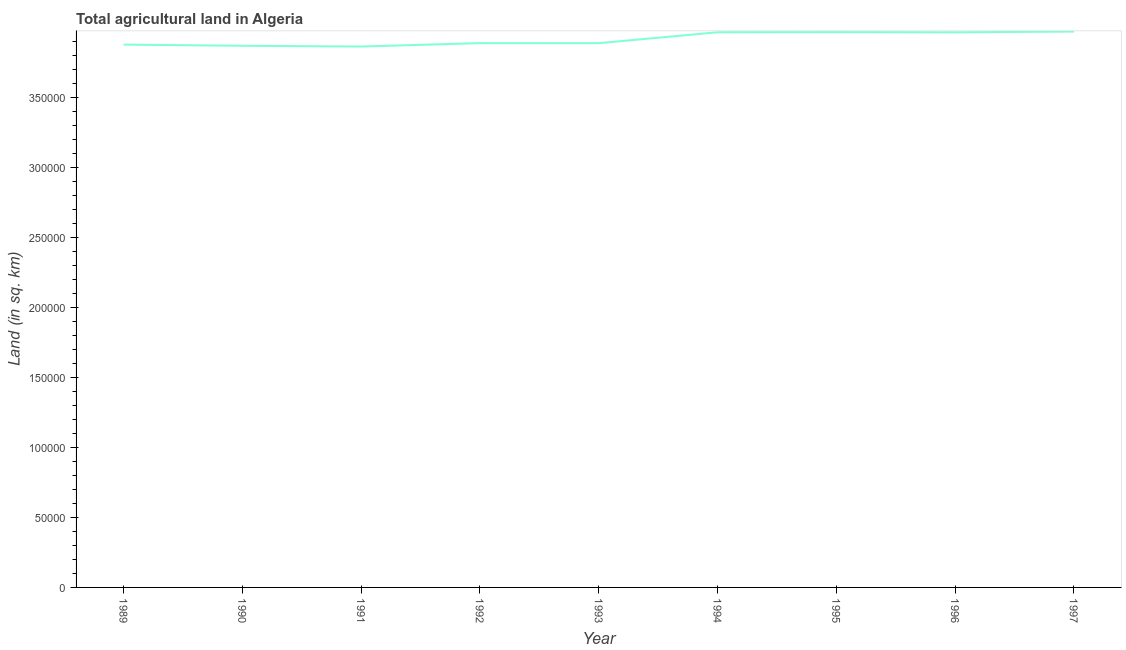What is the agricultural land in 1997?
Offer a terse response. 3.97e+05. Across all years, what is the maximum agricultural land?
Your answer should be compact. 3.97e+05. Across all years, what is the minimum agricultural land?
Make the answer very short. 3.86e+05. In which year was the agricultural land maximum?
Provide a succinct answer. 1997. In which year was the agricultural land minimum?
Provide a short and direct response. 1991. What is the sum of the agricultural land?
Your answer should be very brief. 3.52e+06. What is the difference between the agricultural land in 1991 and 1996?
Make the answer very short. -1.01e+04. What is the average agricultural land per year?
Ensure brevity in your answer.  3.92e+05. What is the median agricultural land?
Ensure brevity in your answer.  3.89e+05. In how many years, is the agricultural land greater than 140000 sq. km?
Provide a succinct answer. 9. What is the ratio of the agricultural land in 1992 to that in 1993?
Make the answer very short. 1. Is the agricultural land in 1991 less than that in 1994?
Your answer should be compact. Yes. Is the difference between the agricultural land in 1989 and 1993 greater than the difference between any two years?
Make the answer very short. No. What is the difference between the highest and the second highest agricultural land?
Offer a very short reply. 410. Is the sum of the agricultural land in 1991 and 1995 greater than the maximum agricultural land across all years?
Provide a short and direct response. Yes. What is the difference between the highest and the lowest agricultural land?
Make the answer very short. 1.07e+04. In how many years, is the agricultural land greater than the average agricultural land taken over all years?
Your response must be concise. 4. How many lines are there?
Offer a terse response. 1. How many years are there in the graph?
Your answer should be compact. 9. Does the graph contain grids?
Your response must be concise. No. What is the title of the graph?
Offer a very short reply. Total agricultural land in Algeria. What is the label or title of the Y-axis?
Ensure brevity in your answer.  Land (in sq. km). What is the Land (in sq. km) of 1989?
Your answer should be compact. 3.88e+05. What is the Land (in sq. km) in 1990?
Give a very brief answer. 3.87e+05. What is the Land (in sq. km) of 1991?
Provide a succinct answer. 3.86e+05. What is the Land (in sq. km) in 1992?
Your answer should be compact. 3.89e+05. What is the Land (in sq. km) of 1993?
Ensure brevity in your answer.  3.89e+05. What is the Land (in sq. km) of 1994?
Keep it short and to the point. 3.96e+05. What is the Land (in sq. km) of 1995?
Give a very brief answer. 3.96e+05. What is the Land (in sq. km) in 1996?
Ensure brevity in your answer.  3.96e+05. What is the Land (in sq. km) of 1997?
Offer a very short reply. 3.97e+05. What is the difference between the Land (in sq. km) in 1989 and 1990?
Your answer should be compact. 840. What is the difference between the Land (in sq. km) in 1989 and 1991?
Offer a very short reply. 1380. What is the difference between the Land (in sq. km) in 1989 and 1992?
Your response must be concise. -1050. What is the difference between the Land (in sq. km) in 1989 and 1993?
Provide a succinct answer. -1020. What is the difference between the Land (in sq. km) in 1989 and 1994?
Keep it short and to the point. -8800. What is the difference between the Land (in sq. km) in 1989 and 1995?
Provide a succinct answer. -8890. What is the difference between the Land (in sq. km) in 1989 and 1996?
Offer a terse response. -8760. What is the difference between the Land (in sq. km) in 1989 and 1997?
Ensure brevity in your answer.  -9300. What is the difference between the Land (in sq. km) in 1990 and 1991?
Provide a short and direct response. 540. What is the difference between the Land (in sq. km) in 1990 and 1992?
Offer a terse response. -1890. What is the difference between the Land (in sq. km) in 1990 and 1993?
Provide a short and direct response. -1860. What is the difference between the Land (in sq. km) in 1990 and 1994?
Give a very brief answer. -9640. What is the difference between the Land (in sq. km) in 1990 and 1995?
Your answer should be very brief. -9730. What is the difference between the Land (in sq. km) in 1990 and 1996?
Provide a short and direct response. -9600. What is the difference between the Land (in sq. km) in 1990 and 1997?
Your response must be concise. -1.01e+04. What is the difference between the Land (in sq. km) in 1991 and 1992?
Make the answer very short. -2430. What is the difference between the Land (in sq. km) in 1991 and 1993?
Offer a very short reply. -2400. What is the difference between the Land (in sq. km) in 1991 and 1994?
Your answer should be compact. -1.02e+04. What is the difference between the Land (in sq. km) in 1991 and 1995?
Give a very brief answer. -1.03e+04. What is the difference between the Land (in sq. km) in 1991 and 1996?
Provide a short and direct response. -1.01e+04. What is the difference between the Land (in sq. km) in 1991 and 1997?
Your response must be concise. -1.07e+04. What is the difference between the Land (in sq. km) in 1992 and 1993?
Give a very brief answer. 30. What is the difference between the Land (in sq. km) in 1992 and 1994?
Your answer should be very brief. -7750. What is the difference between the Land (in sq. km) in 1992 and 1995?
Your answer should be compact. -7840. What is the difference between the Land (in sq. km) in 1992 and 1996?
Keep it short and to the point. -7710. What is the difference between the Land (in sq. km) in 1992 and 1997?
Ensure brevity in your answer.  -8250. What is the difference between the Land (in sq. km) in 1993 and 1994?
Give a very brief answer. -7780. What is the difference between the Land (in sq. km) in 1993 and 1995?
Your answer should be very brief. -7870. What is the difference between the Land (in sq. km) in 1993 and 1996?
Offer a very short reply. -7740. What is the difference between the Land (in sq. km) in 1993 and 1997?
Keep it short and to the point. -8280. What is the difference between the Land (in sq. km) in 1994 and 1995?
Ensure brevity in your answer.  -90. What is the difference between the Land (in sq. km) in 1994 and 1997?
Give a very brief answer. -500. What is the difference between the Land (in sq. km) in 1995 and 1996?
Give a very brief answer. 130. What is the difference between the Land (in sq. km) in 1995 and 1997?
Make the answer very short. -410. What is the difference between the Land (in sq. km) in 1996 and 1997?
Provide a short and direct response. -540. What is the ratio of the Land (in sq. km) in 1989 to that in 1990?
Ensure brevity in your answer.  1. What is the ratio of the Land (in sq. km) in 1990 to that in 1991?
Give a very brief answer. 1. What is the ratio of the Land (in sq. km) in 1990 to that in 1993?
Offer a very short reply. 0.99. What is the ratio of the Land (in sq. km) in 1990 to that in 1994?
Provide a succinct answer. 0.98. What is the ratio of the Land (in sq. km) in 1990 to that in 1995?
Your response must be concise. 0.97. What is the ratio of the Land (in sq. km) in 1991 to that in 1993?
Your answer should be compact. 0.99. What is the ratio of the Land (in sq. km) in 1991 to that in 1994?
Give a very brief answer. 0.97. What is the ratio of the Land (in sq. km) in 1992 to that in 1994?
Offer a terse response. 0.98. What is the ratio of the Land (in sq. km) in 1993 to that in 1995?
Provide a succinct answer. 0.98. What is the ratio of the Land (in sq. km) in 1993 to that in 1997?
Make the answer very short. 0.98. What is the ratio of the Land (in sq. km) in 1994 to that in 1997?
Keep it short and to the point. 1. What is the ratio of the Land (in sq. km) in 1996 to that in 1997?
Your response must be concise. 1. 